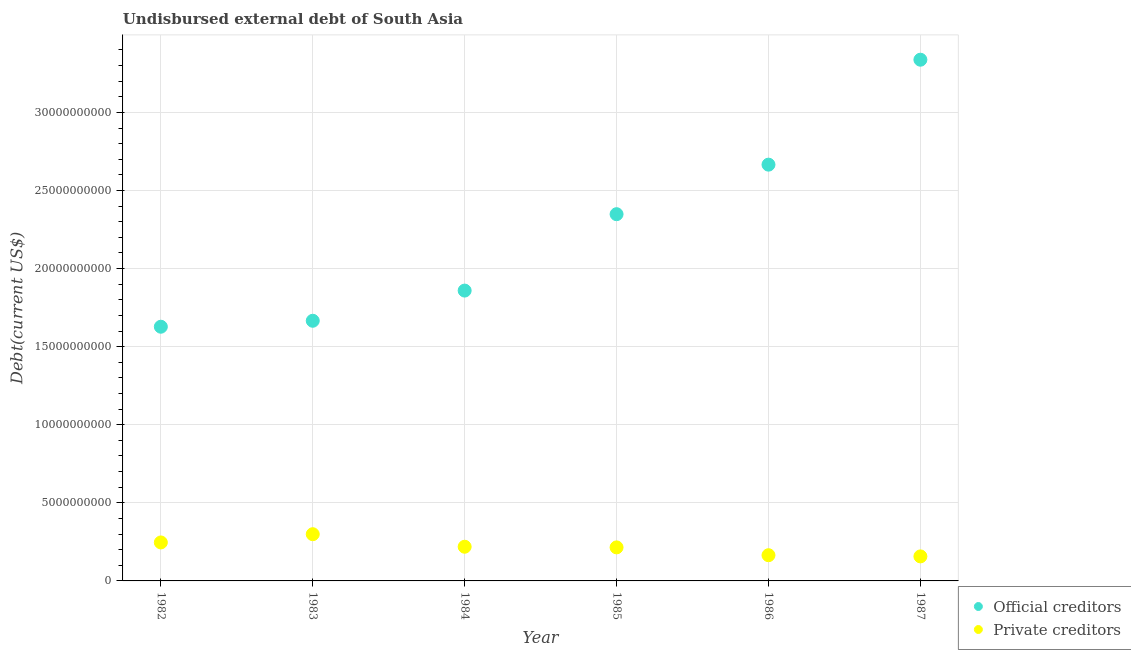How many different coloured dotlines are there?
Your answer should be very brief. 2. Is the number of dotlines equal to the number of legend labels?
Your answer should be very brief. Yes. What is the undisbursed external debt of private creditors in 1986?
Keep it short and to the point. 1.65e+09. Across all years, what is the maximum undisbursed external debt of private creditors?
Your answer should be compact. 2.99e+09. Across all years, what is the minimum undisbursed external debt of official creditors?
Your answer should be compact. 1.63e+1. What is the total undisbursed external debt of official creditors in the graph?
Ensure brevity in your answer.  1.35e+11. What is the difference between the undisbursed external debt of official creditors in 1983 and that in 1987?
Keep it short and to the point. -1.67e+1. What is the difference between the undisbursed external debt of official creditors in 1987 and the undisbursed external debt of private creditors in 1986?
Make the answer very short. 3.17e+1. What is the average undisbursed external debt of official creditors per year?
Your answer should be very brief. 2.25e+1. In the year 1986, what is the difference between the undisbursed external debt of private creditors and undisbursed external debt of official creditors?
Give a very brief answer. -2.50e+1. What is the ratio of the undisbursed external debt of private creditors in 1982 to that in 1983?
Ensure brevity in your answer.  0.82. Is the undisbursed external debt of private creditors in 1983 less than that in 1986?
Offer a terse response. No. Is the difference between the undisbursed external debt of official creditors in 1983 and 1985 greater than the difference between the undisbursed external debt of private creditors in 1983 and 1985?
Your answer should be very brief. No. What is the difference between the highest and the second highest undisbursed external debt of private creditors?
Keep it short and to the point. 5.28e+08. What is the difference between the highest and the lowest undisbursed external debt of private creditors?
Offer a very short reply. 1.42e+09. In how many years, is the undisbursed external debt of private creditors greater than the average undisbursed external debt of private creditors taken over all years?
Your answer should be very brief. 3. Is the sum of the undisbursed external debt of private creditors in 1983 and 1987 greater than the maximum undisbursed external debt of official creditors across all years?
Provide a short and direct response. No. Does the undisbursed external debt of private creditors monotonically increase over the years?
Ensure brevity in your answer.  No. How many years are there in the graph?
Your response must be concise. 6. How are the legend labels stacked?
Keep it short and to the point. Vertical. What is the title of the graph?
Offer a terse response. Undisbursed external debt of South Asia. Does "Agricultural land" appear as one of the legend labels in the graph?
Make the answer very short. No. What is the label or title of the Y-axis?
Offer a very short reply. Debt(current US$). What is the Debt(current US$) in Official creditors in 1982?
Keep it short and to the point. 1.63e+1. What is the Debt(current US$) in Private creditors in 1982?
Your answer should be compact. 2.46e+09. What is the Debt(current US$) of Official creditors in 1983?
Make the answer very short. 1.67e+1. What is the Debt(current US$) in Private creditors in 1983?
Your answer should be very brief. 2.99e+09. What is the Debt(current US$) in Official creditors in 1984?
Your response must be concise. 1.86e+1. What is the Debt(current US$) of Private creditors in 1984?
Give a very brief answer. 2.19e+09. What is the Debt(current US$) of Official creditors in 1985?
Make the answer very short. 2.35e+1. What is the Debt(current US$) in Private creditors in 1985?
Provide a short and direct response. 2.15e+09. What is the Debt(current US$) of Official creditors in 1986?
Make the answer very short. 2.67e+1. What is the Debt(current US$) in Private creditors in 1986?
Provide a succinct answer. 1.65e+09. What is the Debt(current US$) of Official creditors in 1987?
Give a very brief answer. 3.34e+1. What is the Debt(current US$) in Private creditors in 1987?
Offer a very short reply. 1.57e+09. Across all years, what is the maximum Debt(current US$) of Official creditors?
Your response must be concise. 3.34e+1. Across all years, what is the maximum Debt(current US$) in Private creditors?
Your answer should be compact. 2.99e+09. Across all years, what is the minimum Debt(current US$) of Official creditors?
Your response must be concise. 1.63e+1. Across all years, what is the minimum Debt(current US$) of Private creditors?
Your answer should be very brief. 1.57e+09. What is the total Debt(current US$) of Official creditors in the graph?
Your answer should be very brief. 1.35e+11. What is the total Debt(current US$) of Private creditors in the graph?
Offer a very short reply. 1.30e+1. What is the difference between the Debt(current US$) in Official creditors in 1982 and that in 1983?
Provide a succinct answer. -3.82e+08. What is the difference between the Debt(current US$) in Private creditors in 1982 and that in 1983?
Your answer should be very brief. -5.28e+08. What is the difference between the Debt(current US$) in Official creditors in 1982 and that in 1984?
Your response must be concise. -2.31e+09. What is the difference between the Debt(current US$) in Private creditors in 1982 and that in 1984?
Offer a terse response. 2.75e+08. What is the difference between the Debt(current US$) of Official creditors in 1982 and that in 1985?
Give a very brief answer. -7.21e+09. What is the difference between the Debt(current US$) of Private creditors in 1982 and that in 1985?
Provide a succinct answer. 3.16e+08. What is the difference between the Debt(current US$) in Official creditors in 1982 and that in 1986?
Your response must be concise. -1.04e+1. What is the difference between the Debt(current US$) of Private creditors in 1982 and that in 1986?
Give a very brief answer. 8.17e+08. What is the difference between the Debt(current US$) of Official creditors in 1982 and that in 1987?
Provide a succinct answer. -1.71e+1. What is the difference between the Debt(current US$) in Private creditors in 1982 and that in 1987?
Your answer should be compact. 8.93e+08. What is the difference between the Debt(current US$) of Official creditors in 1983 and that in 1984?
Give a very brief answer. -1.93e+09. What is the difference between the Debt(current US$) in Private creditors in 1983 and that in 1984?
Offer a very short reply. 8.03e+08. What is the difference between the Debt(current US$) of Official creditors in 1983 and that in 1985?
Your answer should be very brief. -6.82e+09. What is the difference between the Debt(current US$) of Private creditors in 1983 and that in 1985?
Ensure brevity in your answer.  8.44e+08. What is the difference between the Debt(current US$) in Official creditors in 1983 and that in 1986?
Provide a short and direct response. -1.00e+1. What is the difference between the Debt(current US$) in Private creditors in 1983 and that in 1986?
Provide a succinct answer. 1.34e+09. What is the difference between the Debt(current US$) of Official creditors in 1983 and that in 1987?
Provide a short and direct response. -1.67e+1. What is the difference between the Debt(current US$) of Private creditors in 1983 and that in 1987?
Ensure brevity in your answer.  1.42e+09. What is the difference between the Debt(current US$) of Official creditors in 1984 and that in 1985?
Ensure brevity in your answer.  -4.89e+09. What is the difference between the Debt(current US$) of Private creditors in 1984 and that in 1985?
Provide a short and direct response. 4.15e+07. What is the difference between the Debt(current US$) of Official creditors in 1984 and that in 1986?
Keep it short and to the point. -8.06e+09. What is the difference between the Debt(current US$) of Private creditors in 1984 and that in 1986?
Make the answer very short. 5.42e+08. What is the difference between the Debt(current US$) in Official creditors in 1984 and that in 1987?
Make the answer very short. -1.48e+1. What is the difference between the Debt(current US$) in Private creditors in 1984 and that in 1987?
Provide a succinct answer. 6.18e+08. What is the difference between the Debt(current US$) in Official creditors in 1985 and that in 1986?
Keep it short and to the point. -3.17e+09. What is the difference between the Debt(current US$) of Private creditors in 1985 and that in 1986?
Your response must be concise. 5.01e+08. What is the difference between the Debt(current US$) in Official creditors in 1985 and that in 1987?
Give a very brief answer. -9.89e+09. What is the difference between the Debt(current US$) of Private creditors in 1985 and that in 1987?
Provide a short and direct response. 5.77e+08. What is the difference between the Debt(current US$) of Official creditors in 1986 and that in 1987?
Your response must be concise. -6.72e+09. What is the difference between the Debt(current US$) in Private creditors in 1986 and that in 1987?
Ensure brevity in your answer.  7.61e+07. What is the difference between the Debt(current US$) of Official creditors in 1982 and the Debt(current US$) of Private creditors in 1983?
Make the answer very short. 1.33e+1. What is the difference between the Debt(current US$) in Official creditors in 1982 and the Debt(current US$) in Private creditors in 1984?
Your answer should be compact. 1.41e+1. What is the difference between the Debt(current US$) of Official creditors in 1982 and the Debt(current US$) of Private creditors in 1985?
Ensure brevity in your answer.  1.41e+1. What is the difference between the Debt(current US$) of Official creditors in 1982 and the Debt(current US$) of Private creditors in 1986?
Your answer should be very brief. 1.46e+1. What is the difference between the Debt(current US$) in Official creditors in 1982 and the Debt(current US$) in Private creditors in 1987?
Your response must be concise. 1.47e+1. What is the difference between the Debt(current US$) of Official creditors in 1983 and the Debt(current US$) of Private creditors in 1984?
Your response must be concise. 1.45e+1. What is the difference between the Debt(current US$) in Official creditors in 1983 and the Debt(current US$) in Private creditors in 1985?
Ensure brevity in your answer.  1.45e+1. What is the difference between the Debt(current US$) in Official creditors in 1983 and the Debt(current US$) in Private creditors in 1986?
Keep it short and to the point. 1.50e+1. What is the difference between the Debt(current US$) of Official creditors in 1983 and the Debt(current US$) of Private creditors in 1987?
Keep it short and to the point. 1.51e+1. What is the difference between the Debt(current US$) of Official creditors in 1984 and the Debt(current US$) of Private creditors in 1985?
Keep it short and to the point. 1.64e+1. What is the difference between the Debt(current US$) in Official creditors in 1984 and the Debt(current US$) in Private creditors in 1986?
Provide a short and direct response. 1.69e+1. What is the difference between the Debt(current US$) of Official creditors in 1984 and the Debt(current US$) of Private creditors in 1987?
Keep it short and to the point. 1.70e+1. What is the difference between the Debt(current US$) of Official creditors in 1985 and the Debt(current US$) of Private creditors in 1986?
Give a very brief answer. 2.18e+1. What is the difference between the Debt(current US$) in Official creditors in 1985 and the Debt(current US$) in Private creditors in 1987?
Provide a short and direct response. 2.19e+1. What is the difference between the Debt(current US$) of Official creditors in 1986 and the Debt(current US$) of Private creditors in 1987?
Your response must be concise. 2.51e+1. What is the average Debt(current US$) of Official creditors per year?
Your answer should be very brief. 2.25e+1. What is the average Debt(current US$) of Private creditors per year?
Provide a succinct answer. 2.17e+09. In the year 1982, what is the difference between the Debt(current US$) in Official creditors and Debt(current US$) in Private creditors?
Make the answer very short. 1.38e+1. In the year 1983, what is the difference between the Debt(current US$) in Official creditors and Debt(current US$) in Private creditors?
Make the answer very short. 1.37e+1. In the year 1984, what is the difference between the Debt(current US$) in Official creditors and Debt(current US$) in Private creditors?
Provide a succinct answer. 1.64e+1. In the year 1985, what is the difference between the Debt(current US$) in Official creditors and Debt(current US$) in Private creditors?
Give a very brief answer. 2.13e+1. In the year 1986, what is the difference between the Debt(current US$) of Official creditors and Debt(current US$) of Private creditors?
Offer a terse response. 2.50e+1. In the year 1987, what is the difference between the Debt(current US$) in Official creditors and Debt(current US$) in Private creditors?
Offer a terse response. 3.18e+1. What is the ratio of the Debt(current US$) of Official creditors in 1982 to that in 1983?
Your answer should be very brief. 0.98. What is the ratio of the Debt(current US$) in Private creditors in 1982 to that in 1983?
Provide a short and direct response. 0.82. What is the ratio of the Debt(current US$) in Official creditors in 1982 to that in 1984?
Offer a very short reply. 0.88. What is the ratio of the Debt(current US$) of Private creditors in 1982 to that in 1984?
Keep it short and to the point. 1.13. What is the ratio of the Debt(current US$) of Official creditors in 1982 to that in 1985?
Make the answer very short. 0.69. What is the ratio of the Debt(current US$) in Private creditors in 1982 to that in 1985?
Your answer should be compact. 1.15. What is the ratio of the Debt(current US$) in Official creditors in 1982 to that in 1986?
Give a very brief answer. 0.61. What is the ratio of the Debt(current US$) in Private creditors in 1982 to that in 1986?
Your response must be concise. 1.5. What is the ratio of the Debt(current US$) in Official creditors in 1982 to that in 1987?
Keep it short and to the point. 0.49. What is the ratio of the Debt(current US$) of Private creditors in 1982 to that in 1987?
Your answer should be compact. 1.57. What is the ratio of the Debt(current US$) in Official creditors in 1983 to that in 1984?
Your answer should be very brief. 0.9. What is the ratio of the Debt(current US$) in Private creditors in 1983 to that in 1984?
Offer a terse response. 1.37. What is the ratio of the Debt(current US$) of Official creditors in 1983 to that in 1985?
Your response must be concise. 0.71. What is the ratio of the Debt(current US$) in Private creditors in 1983 to that in 1985?
Your response must be concise. 1.39. What is the ratio of the Debt(current US$) in Official creditors in 1983 to that in 1986?
Your answer should be very brief. 0.62. What is the ratio of the Debt(current US$) in Private creditors in 1983 to that in 1986?
Provide a short and direct response. 1.82. What is the ratio of the Debt(current US$) of Official creditors in 1983 to that in 1987?
Offer a very short reply. 0.5. What is the ratio of the Debt(current US$) in Private creditors in 1983 to that in 1987?
Offer a very short reply. 1.9. What is the ratio of the Debt(current US$) in Official creditors in 1984 to that in 1985?
Provide a succinct answer. 0.79. What is the ratio of the Debt(current US$) in Private creditors in 1984 to that in 1985?
Provide a short and direct response. 1.02. What is the ratio of the Debt(current US$) of Official creditors in 1984 to that in 1986?
Provide a succinct answer. 0.7. What is the ratio of the Debt(current US$) in Private creditors in 1984 to that in 1986?
Provide a short and direct response. 1.33. What is the ratio of the Debt(current US$) in Official creditors in 1984 to that in 1987?
Your answer should be very brief. 0.56. What is the ratio of the Debt(current US$) of Private creditors in 1984 to that in 1987?
Make the answer very short. 1.39. What is the ratio of the Debt(current US$) in Official creditors in 1985 to that in 1986?
Give a very brief answer. 0.88. What is the ratio of the Debt(current US$) of Private creditors in 1985 to that in 1986?
Make the answer very short. 1.3. What is the ratio of the Debt(current US$) of Official creditors in 1985 to that in 1987?
Ensure brevity in your answer.  0.7. What is the ratio of the Debt(current US$) of Private creditors in 1985 to that in 1987?
Your answer should be very brief. 1.37. What is the ratio of the Debt(current US$) of Official creditors in 1986 to that in 1987?
Provide a short and direct response. 0.8. What is the ratio of the Debt(current US$) of Private creditors in 1986 to that in 1987?
Provide a succinct answer. 1.05. What is the difference between the highest and the second highest Debt(current US$) in Official creditors?
Offer a terse response. 6.72e+09. What is the difference between the highest and the second highest Debt(current US$) of Private creditors?
Offer a very short reply. 5.28e+08. What is the difference between the highest and the lowest Debt(current US$) in Official creditors?
Give a very brief answer. 1.71e+1. What is the difference between the highest and the lowest Debt(current US$) in Private creditors?
Provide a succinct answer. 1.42e+09. 